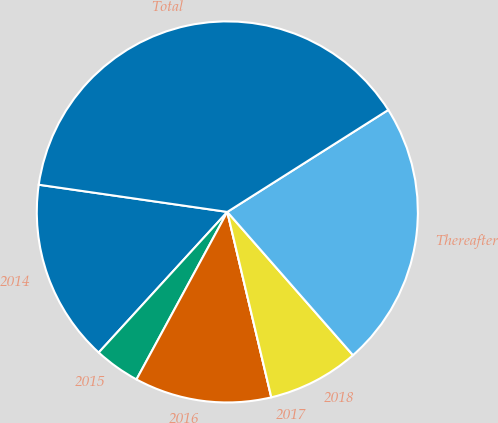<chart> <loc_0><loc_0><loc_500><loc_500><pie_chart><fcel>2014<fcel>2015<fcel>2016<fcel>2017<fcel>2018<fcel>Thereafter<fcel>Total<nl><fcel>15.49%<fcel>3.88%<fcel>11.62%<fcel>0.0%<fcel>7.75%<fcel>22.53%<fcel>38.73%<nl></chart> 